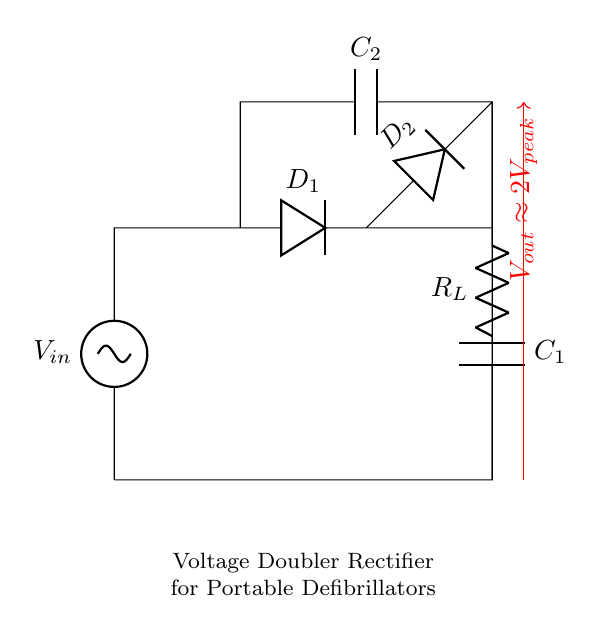What is the peak voltage input for this circuit? The input voltage source is labeled as V_in, which denotes the initial input voltage to the circuit, specifically, the peak voltage of the AC signal supplied.
Answer: V_in What type of diodes are used in this circuit? The circuit diagram features two components labeled as D_1 and D_2, which represent the diodes used in the rectification process. Typically, these are silicon diodes suitable for rectification in voltage doubler applications.
Answer: Silicon diodes What component is responsible for storing charge in this circuit? The circuit contains two capacitors labeled as C_1 and C_2. In a voltage doubler rectifier, these capacitors accumulate charge during the rectification process, providing increased output voltage.
Answer: Capacitors What is the approximate output voltage of this circuit? The output voltage is indicated on the diagram as V_out, with a note stating that V_out is approximately 2 times the peak input voltage, reflected in the formula for a standard resistor-capacitor voltage doubler configuration.
Answer: 2V_peak How do the diodes operate in this circuit? The circuit utilizes a series of diodes (D_1 and D_2) which allow current to flow during specific half-cycles of the input AC signal, effectively rectifying the input and directing charge to the capacitors for voltage doubling. In DC analysis, D_1 conducts during one half-cycle, while D_2 conducts in the other, ensuring correct operation of the voltage doubler.
Answer: They rectify the AC voltage 